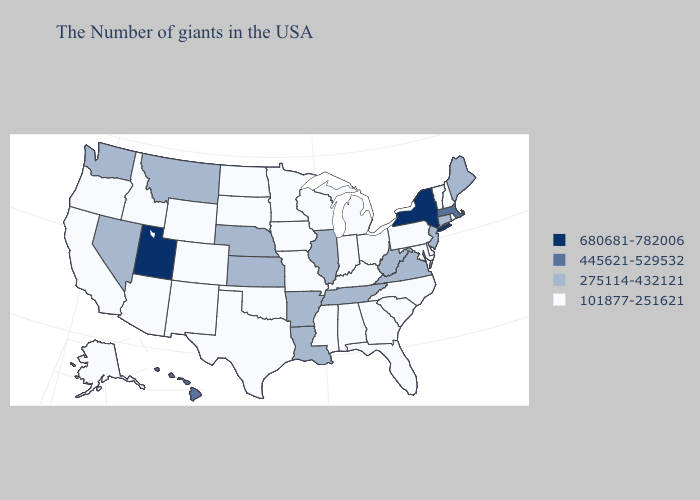What is the value of Ohio?
Be succinct. 101877-251621. Does Arkansas have the highest value in the USA?
Write a very short answer. No. Name the states that have a value in the range 680681-782006?
Write a very short answer. New York, Utah. What is the value of Oklahoma?
Concise answer only. 101877-251621. What is the lowest value in the USA?
Answer briefly. 101877-251621. Does Hawaii have the lowest value in the USA?
Concise answer only. No. Does Georgia have a lower value than West Virginia?
Keep it brief. Yes. Does Nebraska have the lowest value in the MidWest?
Give a very brief answer. No. What is the lowest value in the USA?
Give a very brief answer. 101877-251621. Name the states that have a value in the range 445621-529532?
Keep it brief. Massachusetts, Hawaii. What is the value of Wyoming?
Answer briefly. 101877-251621. What is the value of Delaware?
Answer briefly. 101877-251621. What is the value of Kansas?
Be succinct. 275114-432121. Among the states that border New Jersey , which have the highest value?
Be succinct. New York. Does Alabama have the same value as Oklahoma?
Quick response, please. Yes. 